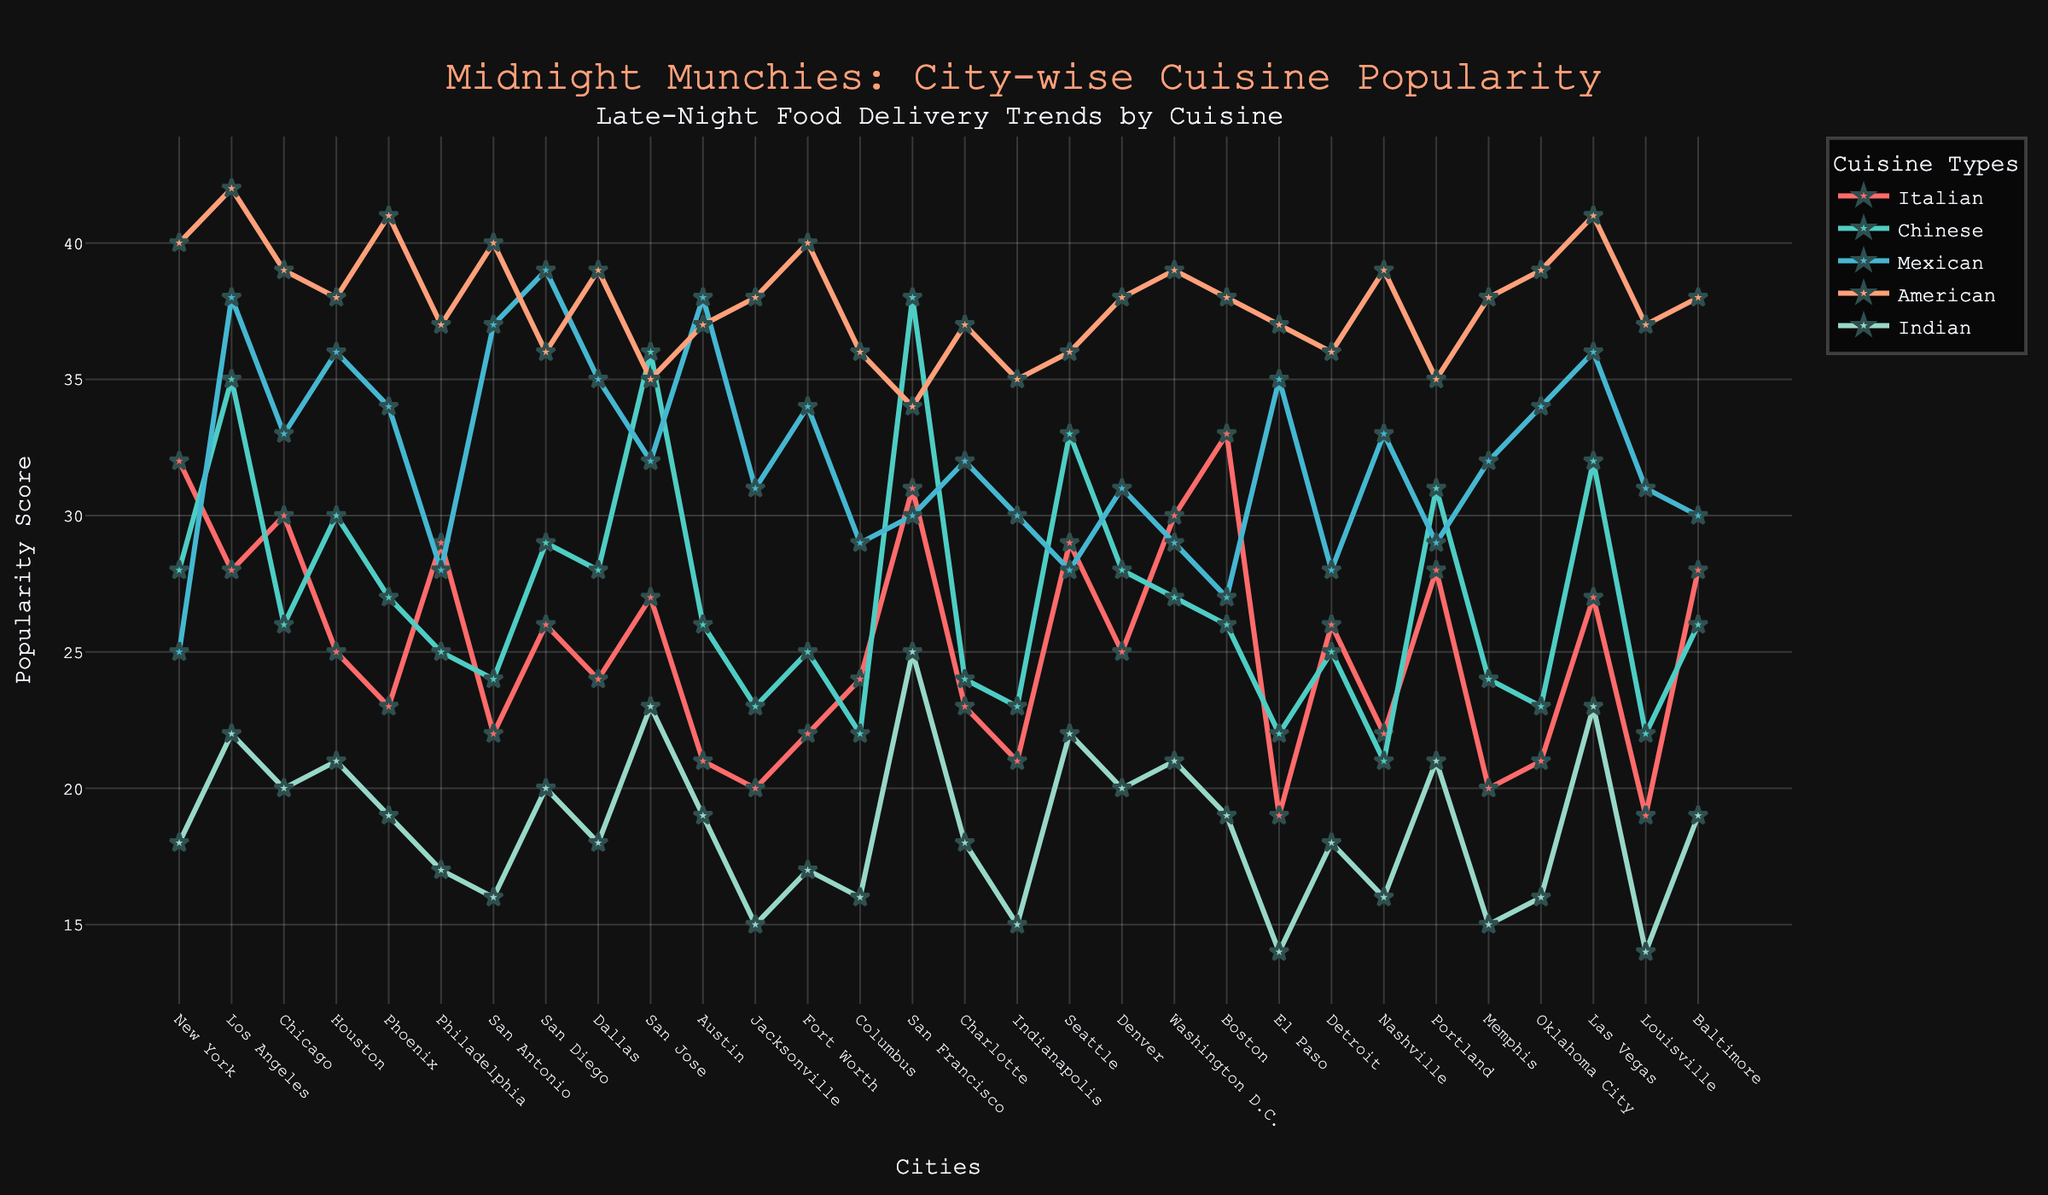What is the most popular cuisine type overall in late-night food deliveries across all cities? First, we need to find the highest value across all cuisine types in the chart. American cuisine scores the highest in multiple cities such as San Jose, Phoenix, Los Angeles, etc.
Answer: American Among the cities listed, which city has the highest popularity score for Italian cuisine? By examining the Italian cuisine line (in red) in the chart, we can see that Boston has the highest score of 33 for Italian cuisine.
Answer: Boston Which cuisine has the least popularity score in Philadelphia? Looking at the various cuisine lines for Philadelphia, Indian cuisine has the lowest value of 17.
Answer: Indian Compare the popularity of Mexican cuisine in Austin and Dallas. Which city has a higher score? Checking the Mexican cuisine scores on the chart, Austin has a score of 38 while Dallas has a score of 35, making Austin higher.
Answer: Austin What is the average popularity score for Indian cuisine across all cities? To calculate the average: sum the scores (18+22+20+21+19+17+16+20+18+23+19+15+17+16+25+18+15+22+20+21+19+14+18+16+21+15+16+23+14+19) = 532. Divide by the number of cities (30). The average is 532/30 = 17.73
Answer: 17.73 In terms of Chinese cuisine trends, how does San Francisco compare with Las Vegas? San Francisco's score for Chinese cuisine is 38, while Las Vegas's score is 32. San Francisco is higher by 6 points.
Answer: San Francisco For American cuisine, which city shows the least popularity, and what is the score? Reviewing the American cuisine line (in peach color), San Francisco shows the least score of 34 for American cuisine.
Answer: San Francisco What is the total sum of popularity scores for Italian cuisine across all cities? Adding all the scores for Italian cuisine (32+28+30+25+23+29+22+26+24+27+21+20+22+24+31+23+21+29+25+30+33+19+26+22+28+20+21+27+19+28) = 624
Answer: 624 Compare the highest popularity score for Indian cuisine and the lowest popularity score for Chinese cuisine. Which one is higher and by how much? The highest score for Indian cuisine is 25 (in San Francisco), while the lowest score for Chinese cuisine is 21 (in Nashville). The difference is 25 - 21 = 4, with Indian cuisine being higher.
Answer: Indian cuisine by 4 